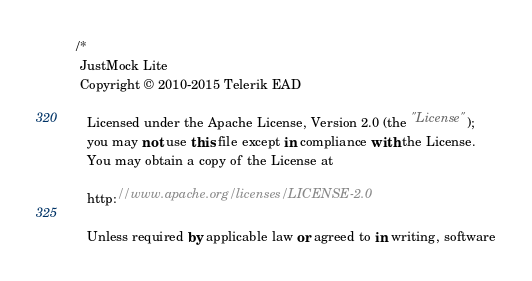<code> <loc_0><loc_0><loc_500><loc_500><_C#_>/*
 JustMock Lite
 Copyright © 2010-2015 Telerik EAD

   Licensed under the Apache License, Version 2.0 (the "License");
   you may not use this file except in compliance with the License.
   You may obtain a copy of the License at

   http://www.apache.org/licenses/LICENSE-2.0

   Unless required by applicable law or agreed to in writing, software</code> 